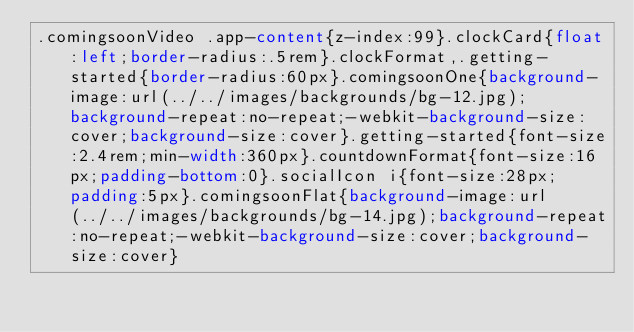Convert code to text. <code><loc_0><loc_0><loc_500><loc_500><_CSS_>.comingsoonVideo .app-content{z-index:99}.clockCard{float:left;border-radius:.5rem}.clockFormat,.getting-started{border-radius:60px}.comingsoonOne{background-image:url(../../images/backgrounds/bg-12.jpg);background-repeat:no-repeat;-webkit-background-size:cover;background-size:cover}.getting-started{font-size:2.4rem;min-width:360px}.countdownFormat{font-size:16px;padding-bottom:0}.socialIcon i{font-size:28px;padding:5px}.comingsoonFlat{background-image:url(../../images/backgrounds/bg-14.jpg);background-repeat:no-repeat;-webkit-background-size:cover;background-size:cover}</code> 